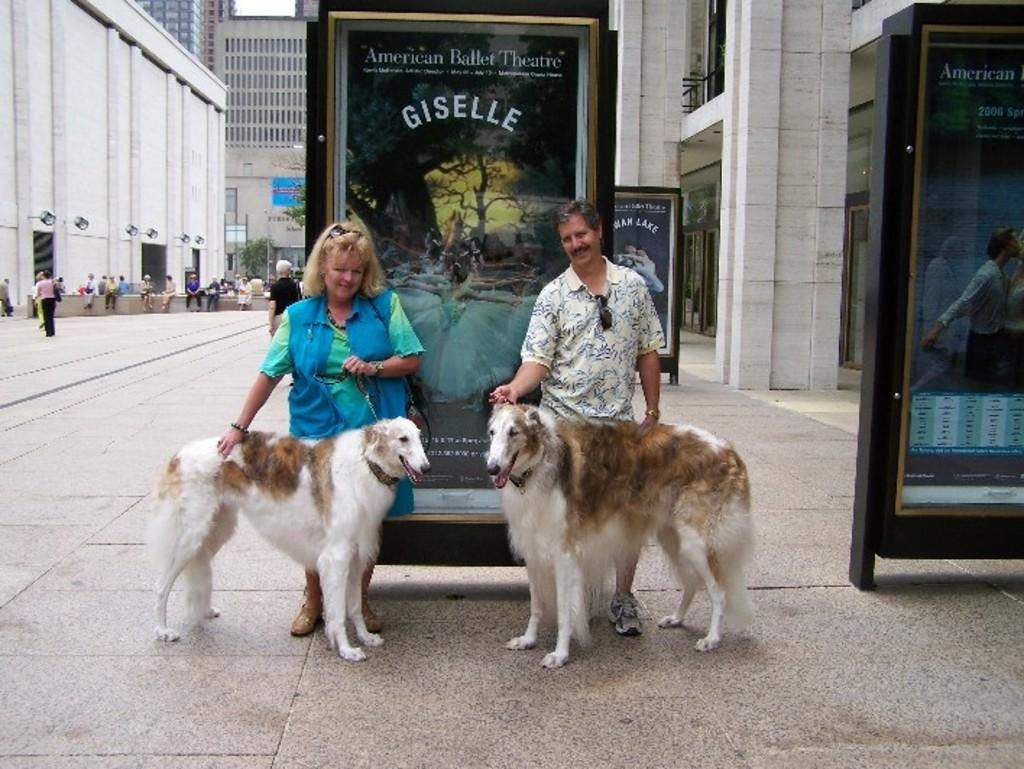What types of living organisms can be seen in the image? There are animals in the image. How many people are standing in the image? Two persons are standing on the floor in the image. What can be seen on the walls or structures in the image? There are hoardings in the image. Can you describe the people present in the image? There are people in the image. What else is visible in the image besides the people and animals? There are objects in the image. What can be seen in the distance in the image? There are buildings in the background of the image. What type of sleet can be seen falling from the sky in the image? There is no sleet present in the image; it does not depict any weather conditions. Can you tell me how many jars are being used by the people in the image? There is no mention of jars in the image; no such objects are present. 